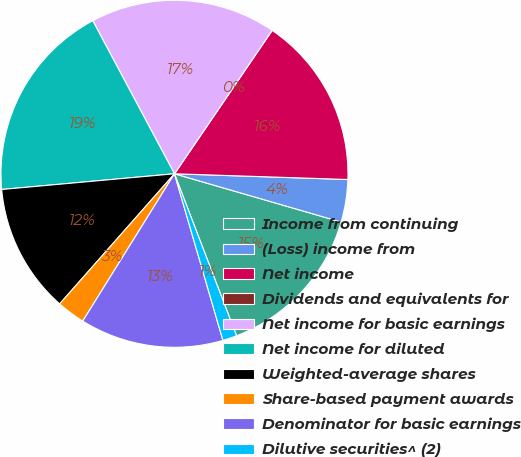<chart> <loc_0><loc_0><loc_500><loc_500><pie_chart><fcel>Income from continuing<fcel>(Loss) income from<fcel>Net income<fcel>Dividends and equivalents for<fcel>Net income for basic earnings<fcel>Net income for diluted<fcel>Weighted-average shares<fcel>Share-based payment awards<fcel>Denominator for basic earnings<fcel>Dilutive securities^ (2)<nl><fcel>14.69%<fcel>3.96%<fcel>16.01%<fcel>0.0%<fcel>17.32%<fcel>18.64%<fcel>12.05%<fcel>2.64%<fcel>13.37%<fcel>1.32%<nl></chart> 